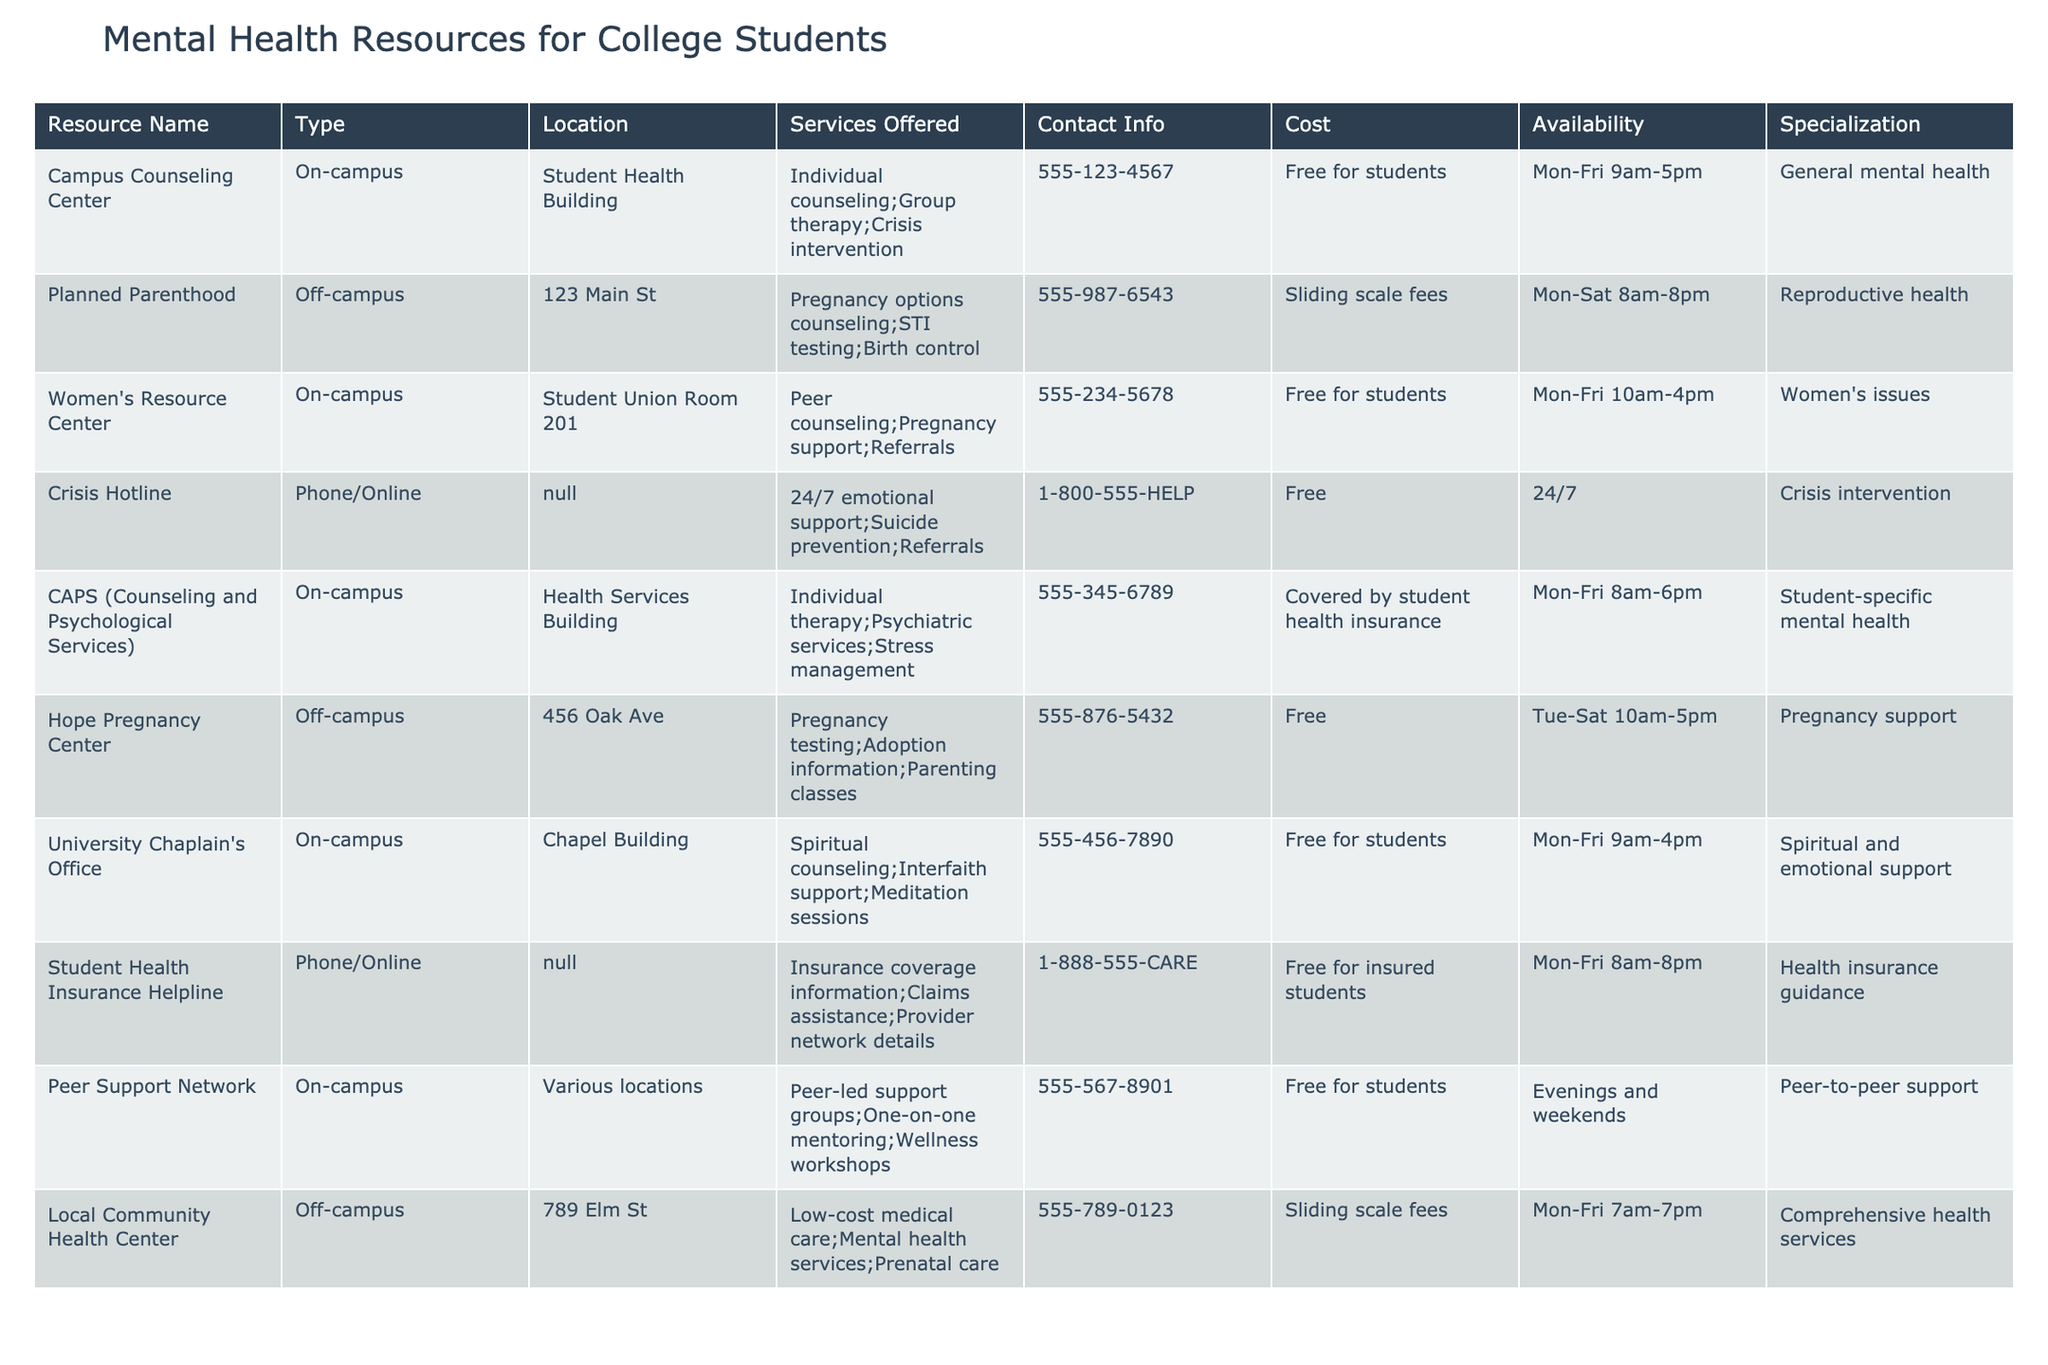What are the services offered by the Women's Resource Center? The Women's Resource Center offers peer counseling, pregnancy support, and referrals. This information can be found in the "Services Offered" column for that specific resource.
Answer: Peer counseling; Pregnancy support; Referrals Is there a resource available for crisis intervention? Yes, the Crisis Hotline provides 24/7 emotional support and crisis intervention services, as indicated in the "Services Offered" column.
Answer: Yes Which on-campus resource is available from 8 am to 6 pm? The Counseling and Psychological Services (CAPS) operates from 8 am to 6 pm, as shown in the "Availability" column.
Answer: CAPS (Counseling and Psychological Services) How many resources are free for students? There are four resources listed that are free for students: Campus Counseling Center, Women's Resource Center, University Chaplain's Office, and Peer Support Network. This is determined by counting the resources that have "Free for students" in the "Cost" column.
Answer: Four What type of services does Planned Parenthood offer? Planned Parenthood offers pregnancy options counseling, STI testing, and birth control, according to the "Services Offered" column.
Answer: Pregnancy options counseling; STI testing; Birth control How many resources have a specialization related to pregnancy support? There are three resources specializing in pregnancy support: Hope Pregnancy Center, Women's Resource Center, and Planned Parenthood. This is found by identifying resources specifically mentioning pregnancy support in the "Specialization" column.
Answer: Three Does the Local Community Health Center provide mental health services? Yes, the Local Community Health Center provides mental health services, which is mentioned in the "Services Offered" column.
Answer: Yes What is the contact information for the Hope Pregnancy Center? The contact information for the Hope Pregnancy Center is 555-876-5432, as noted in the "Contact Info" column for that resource.
Answer: 555-876-5432 Which resource is available for peer-to-peer support? The Peer Support Network is available for peer-to-peer support, indicated under the "Services Offered" column.
Answer: Peer Support Network If a student is seeking spiritual counseling, which resource should they contact? A student seeking spiritual counseling should contact the University Chaplain's Office, which specializes in spiritual and emotional support as per the "Specialization" column.
Answer: University Chaplain's Office 